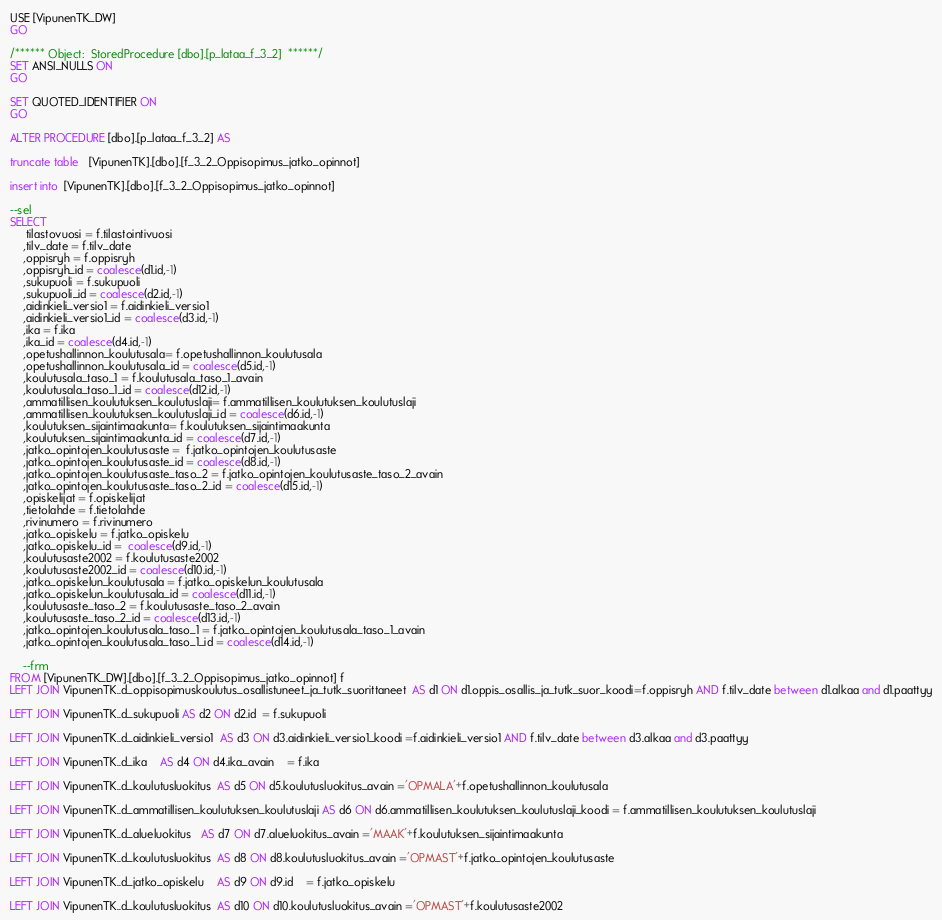<code> <loc_0><loc_0><loc_500><loc_500><_SQL_>USE [VipunenTK_DW]
GO

/****** Object:  StoredProcedure [dbo].[p_lataa_f_3_2]  ******/
SET ANSI_NULLS ON
GO

SET QUOTED_IDENTIFIER ON
GO

ALTER PROCEDURE [dbo].[p_lataa_f_3_2] AS

truncate table   [VipunenTK].[dbo].[f_3_2_Oppisopimus_jatko_opinnot]

insert into  [VipunenTK].[dbo].[f_3_2_Oppisopimus_jatko_opinnot]

--sel
SELECT
	 tilastovuosi = f.tilastointivuosi
	,tilv_date = f.tilv_date
	,oppisryh = f.oppisryh
	,oppisryh_id = coalesce(d1.id,-1)
	,sukupuoli = f.sukupuoli
	,sukupuoli_id = coalesce(d2.id,-1)
	,aidinkieli_versio1 = f.aidinkieli_versio1
	,aidinkieli_versio1_id = coalesce(d3.id,-1)
	,ika = f.ika
	,ika_id = coalesce(d4.id,-1)
	,opetushallinnon_koulutusala= f.opetushallinnon_koulutusala
	,opetushallinnon_koulutusala_id = coalesce(d5.id,-1)
	,koulutusala_taso_1 = f.koulutusala_taso_1_avain
	,koulutusala_taso_1_id = coalesce(d12.id,-1)
	,ammatillisen_koulutuksen_koulutuslaji= f.ammatillisen_koulutuksen_koulutuslaji
	,ammatillisen_koulutuksen_koulutuslaji_id = coalesce(d6.id,-1)
	,koulutuksen_sijaintimaakunta= f.koulutuksen_sijaintimaakunta
	,koulutuksen_sijaintimaakunta_id = coalesce(d7.id,-1)
	,jatko_opintojen_koulutusaste =  f.jatko_opintojen_koulutusaste
	,jatko_opintojen_koulutusaste_id = coalesce(d8.id,-1)
	,jatko_opintojen_koulutusaste_taso_2 = f.jatko_opintojen_koulutusaste_taso_2_avain
	,jatko_opintojen_koulutusaste_taso_2_id = coalesce(d15.id,-1)
    ,opiskelijat = f.opiskelijat
    ,tietolahde = f.tietolahde
    ,rivinumero = f.rivinumero
	,jatko_opiskelu = f.jatko_opiskelu
	,jatko_opiskelu_id =  coalesce(d9.id,-1)
	,koulutusaste2002 = f.koulutusaste2002
	,koulutusaste2002_id = coalesce(d10.id,-1)
	,jatko_opiskelun_koulutusala = f.jatko_opiskelun_koulutusala
	,jatko_opiskelun_koulutusala_id = coalesce(d11.id,-1)
	,koulutusaste_taso_2 = f.koulutusaste_taso_2_avain
	,koulutusaste_taso_2_id = coalesce(d13.id,-1)
	,jatko_opintojen_koulutusala_taso_1 = f.jatko_opintojen_koulutusala_taso_1_avain
	,jatko_opintojen_koulutusala_taso_1_id = coalesce(d14.id,-1)
    
    --frm
FROM [VipunenTK_DW].[dbo].[f_3_2_Oppisopimus_jatko_opinnot] f
LEFT JOIN VipunenTK..d_oppisopimuskoulutus_osallistuneet_ja_tutk_suorittaneet  AS d1 ON d1.oppis_osallis_ja_tutk_suor_koodi=f.oppisryh AND f.tilv_date between d1.alkaa and d1.paattyy

LEFT JOIN VipunenTK..d_sukupuoli AS d2 ON d2.id  = f.sukupuoli

LEFT JOIN VipunenTK..d_aidinkieli_versio1  AS d3 ON d3.aidinkieli_versio1_koodi =f.aidinkieli_versio1 AND f.tilv_date between d3.alkaa and d3.paattyy

LEFT JOIN VipunenTK..d_ika    AS d4 ON d4.ika_avain    = f.ika

LEFT JOIN VipunenTK..d_koulutusluokitus  AS d5 ON d5.koulutusluokitus_avain ='OPMALA'+f.opetushallinnon_koulutusala

LEFT JOIN VipunenTK..d_ammatillisen_koulutuksen_koulutuslaji AS d6 ON d6.ammatillisen_koulutuksen_koulutuslaji_koodi = f.ammatillisen_koulutuksen_koulutuslaji

LEFT JOIN VipunenTK..d_alueluokitus   AS d7 ON d7.alueluokitus_avain ='MAAK'+f.koulutuksen_sijaintimaakunta

LEFT JOIN VipunenTK..d_koulutusluokitus  AS d8 ON d8.koulutusluokitus_avain ='OPMAST'+f.jatko_opintojen_koulutusaste

LEFT JOIN VipunenTK..d_jatko_opiskelu    AS d9 ON d9.id    = f.jatko_opiskelu

LEFT JOIN VipunenTK..d_koulutusluokitus  AS d10 ON d10.koulutusluokitus_avain ='OPMAST'+f.koulutusaste2002
</code> 